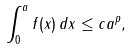Convert formula to latex. <formula><loc_0><loc_0><loc_500><loc_500>\int _ { 0 } ^ { a } f ( x ) \, d x \leq c a ^ { p } ,</formula> 